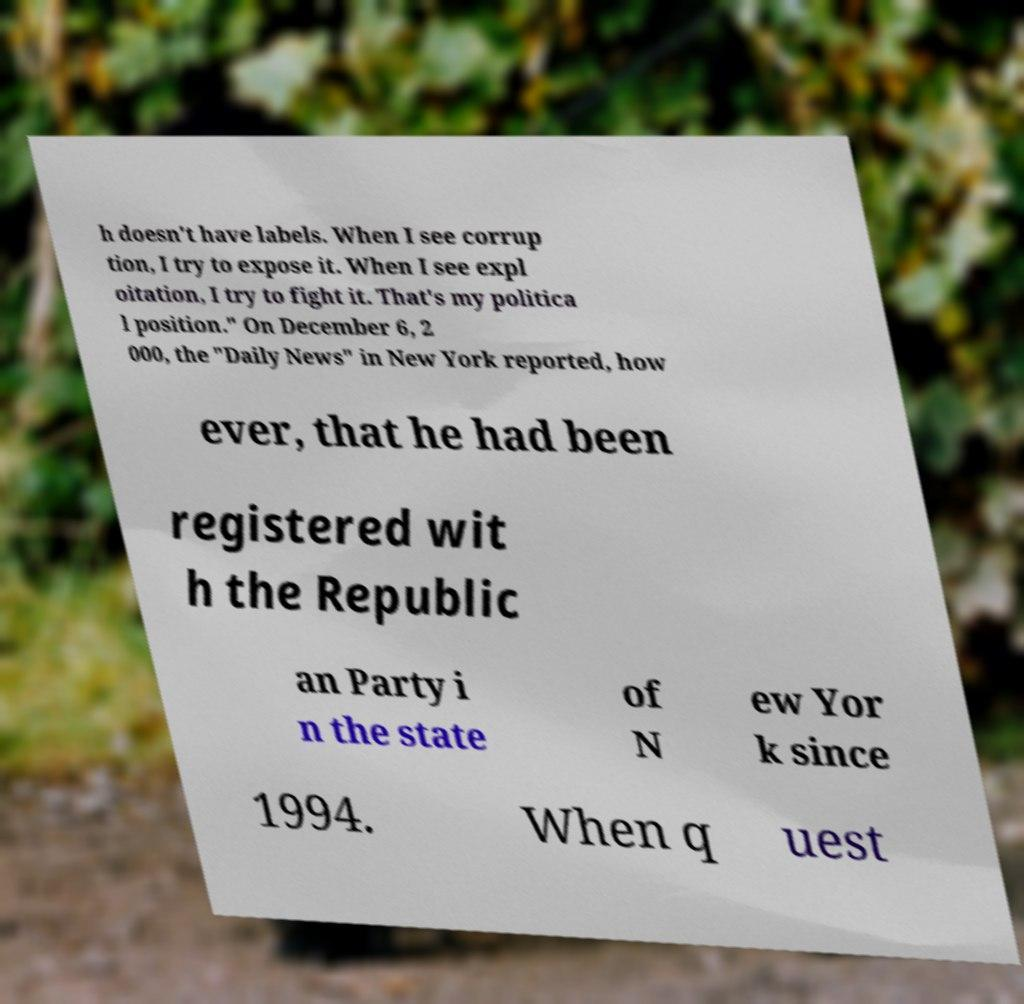For documentation purposes, I need the text within this image transcribed. Could you provide that? h doesn't have labels. When I see corrup tion, I try to expose it. When I see expl oitation, I try to fight it. That's my politica l position." On December 6, 2 000, the "Daily News" in New York reported, how ever, that he had been registered wit h the Republic an Party i n the state of N ew Yor k since 1994. When q uest 